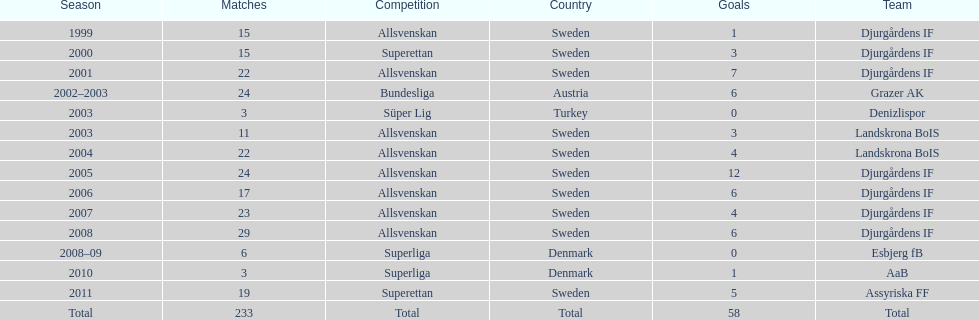What was the quantity of goals he scored in 2005? 12. 